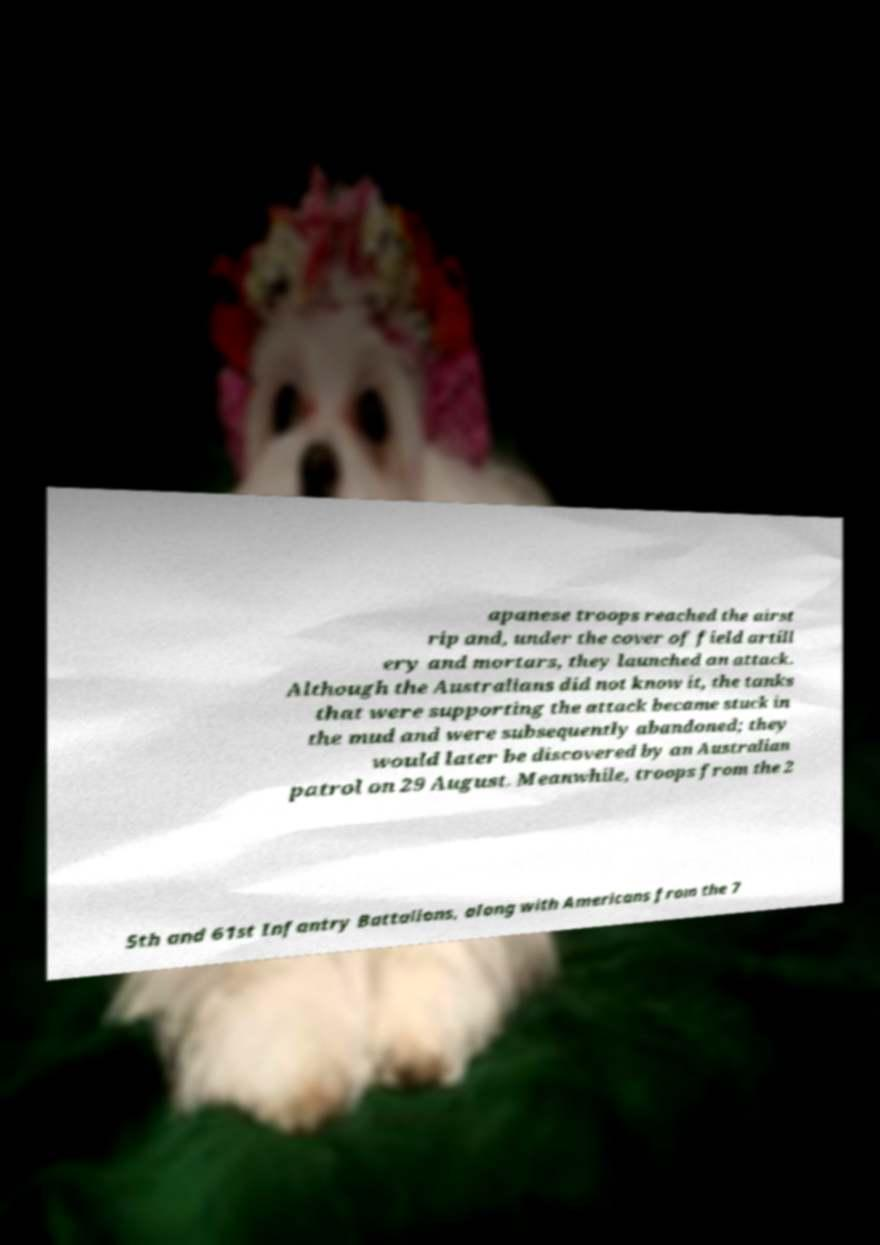Can you read and provide the text displayed in the image?This photo seems to have some interesting text. Can you extract and type it out for me? apanese troops reached the airst rip and, under the cover of field artill ery and mortars, they launched an attack. Although the Australians did not know it, the tanks that were supporting the attack became stuck in the mud and were subsequently abandoned; they would later be discovered by an Australian patrol on 29 August. Meanwhile, troops from the 2 5th and 61st Infantry Battalions, along with Americans from the 7 